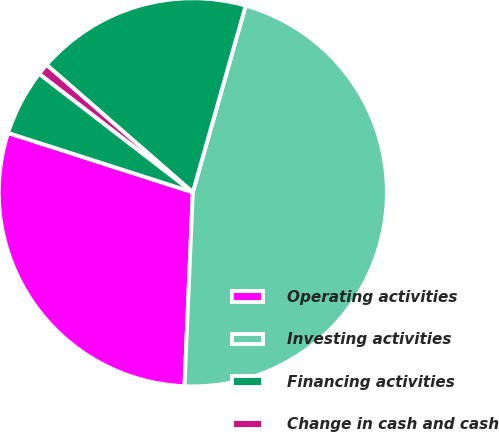<chart> <loc_0><loc_0><loc_500><loc_500><pie_chart><fcel>Operating activities<fcel>Investing activities<fcel>Financing activities<fcel>Change in cash and cash<fcel>Cash and cash equivalents at<nl><fcel>29.27%<fcel>46.29%<fcel>17.98%<fcel>0.96%<fcel>5.5%<nl></chart> 